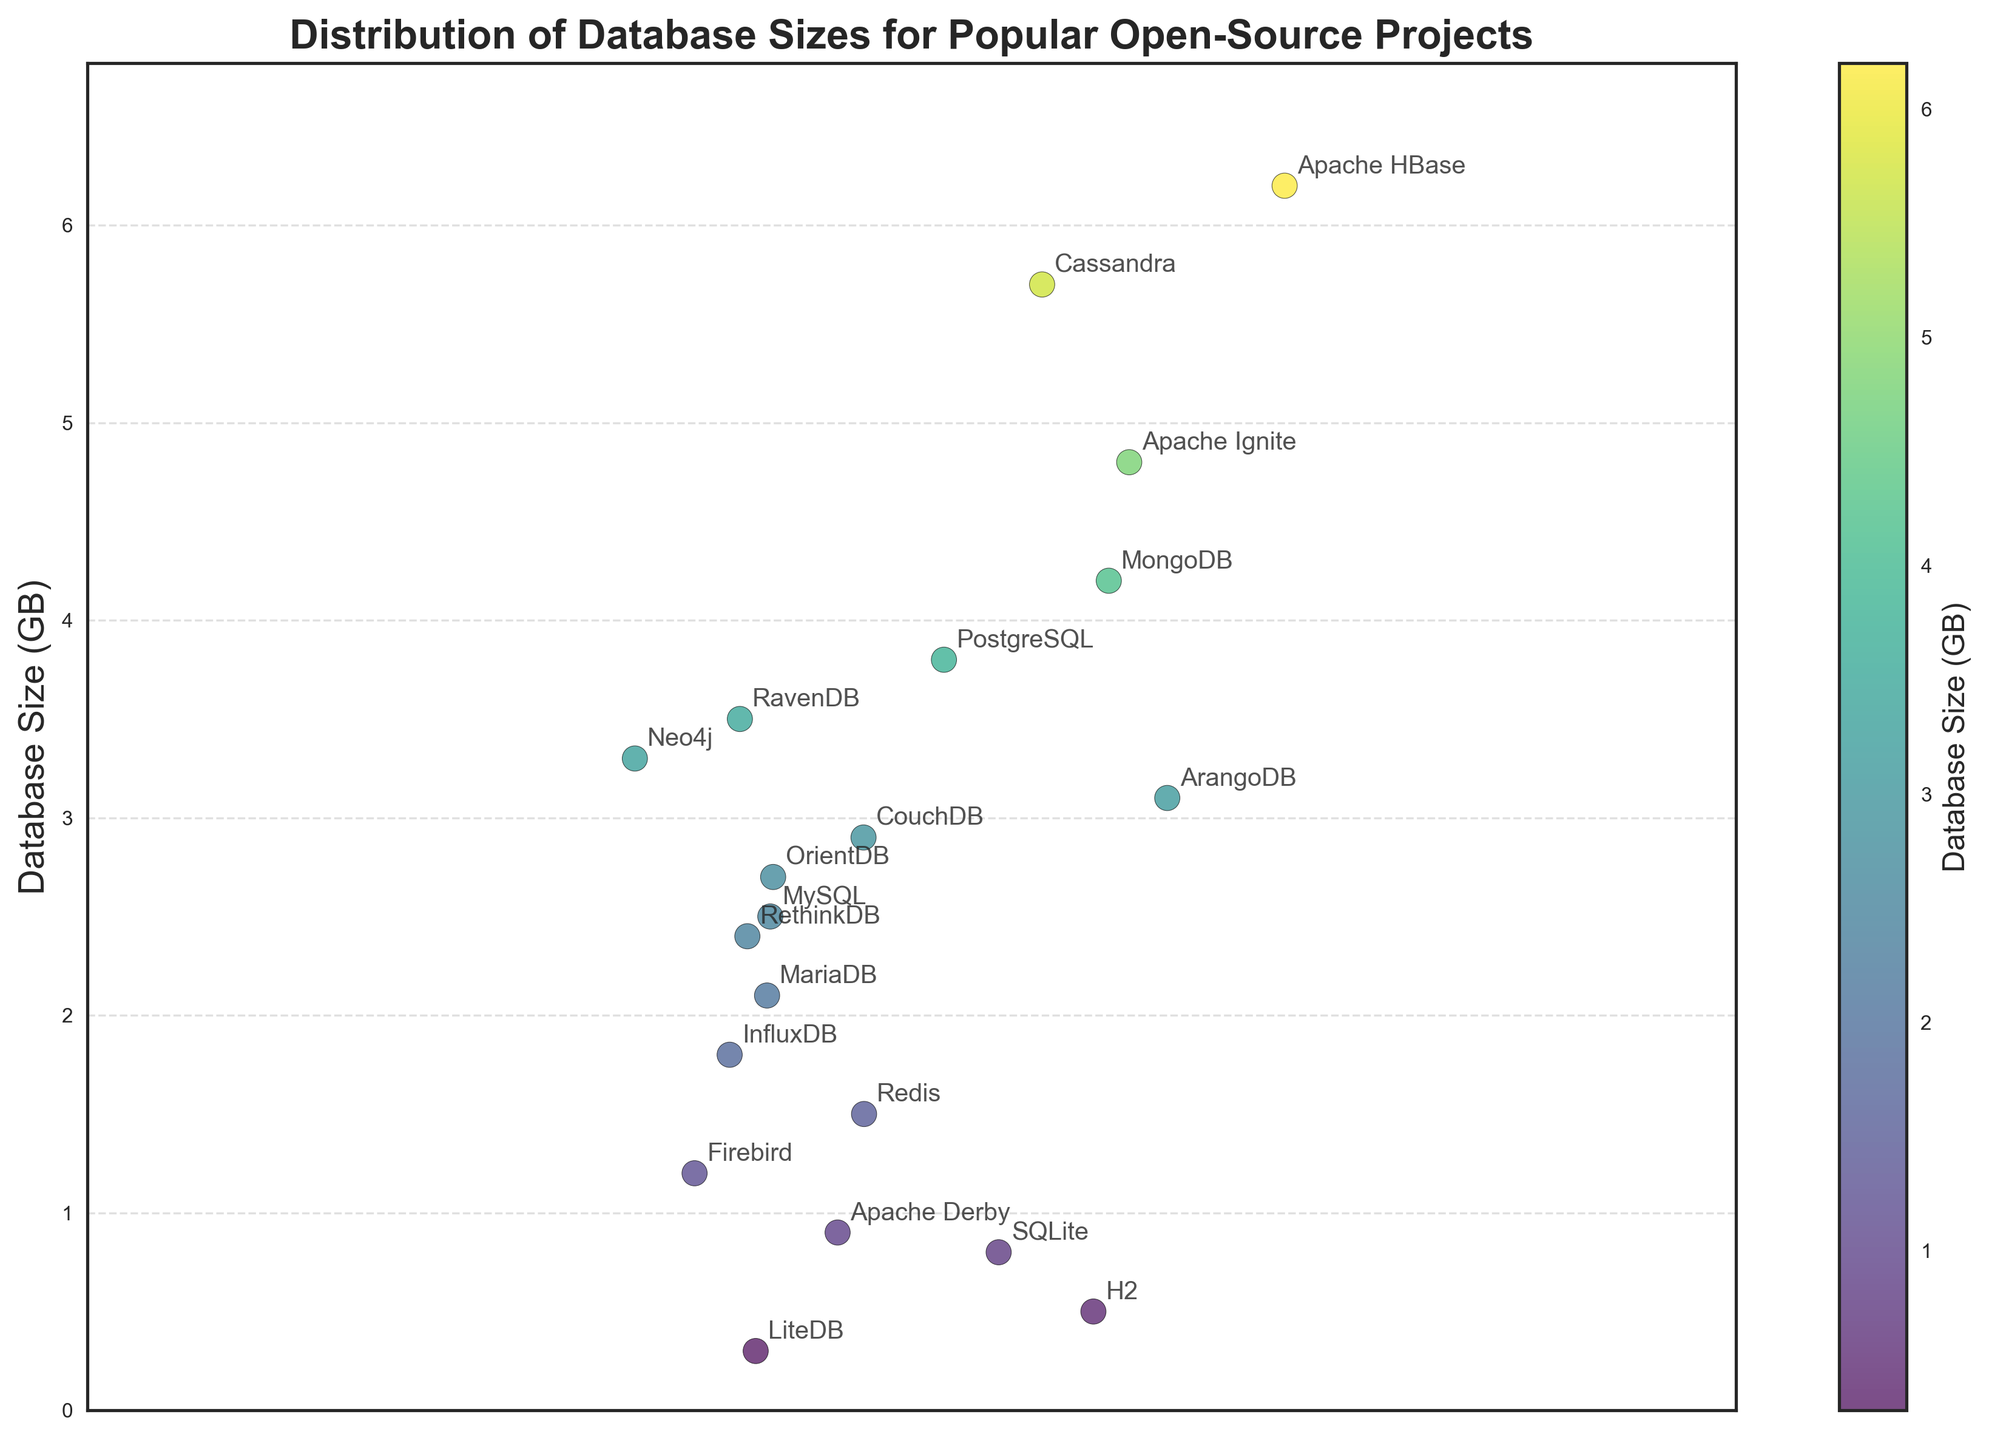How many projects are shown in the plot? The plot displays each data point, one for each project. Counting the points shows how many projects are included.
Answer: 20 Which project has the largest database size? The highest point on the vertical axis represents the largest database size, and the annotation near it shows the project's name.
Answer: Apache HBase Which project has the smallest database size? The lowest point on the vertical axis represents the smallest database size, and the annotation near it shows the project's name.
Answer: LiteDB What's the range of database sizes in the plot? The range is found by subtracting the smallest size from the largest size. Here, it’s the difference between Apache HBase (6.2 GB) and LiteDB (0.3 GB).
Answer: 5.9 GB How many projects have a database size greater than 3.0 GB? Count the data points above the 3.0 GB mark on the vertical axis and refer to their project annotations.
Answer: 8 Which two projects have the closest database sizes? Look for points that are closest vertically on the plot, and check their database sizes.
Answer: RethinkDB and MariaDB Are there more projects with database sizes below or above 2.0 GB? Count the number of data points below and above the 2.0 GB mark on the vertical axis.
Answer: Below What is the median database size of all the projects? Arrange all the database sizes in increasing order and find the middle value.
Answer: 2.5 GB Which project falls closest to the average database size? Calculate the mean of all database sizes, then find the project whose size is closest to this mean on the plot.
Answer: ArangoDB Is there any project with a database size close to 1.0 GB? Identify any data points that are very close to the 1.0 GB mark on the vertical axis and refer to their project annotations.
Answer: Apache Derby 